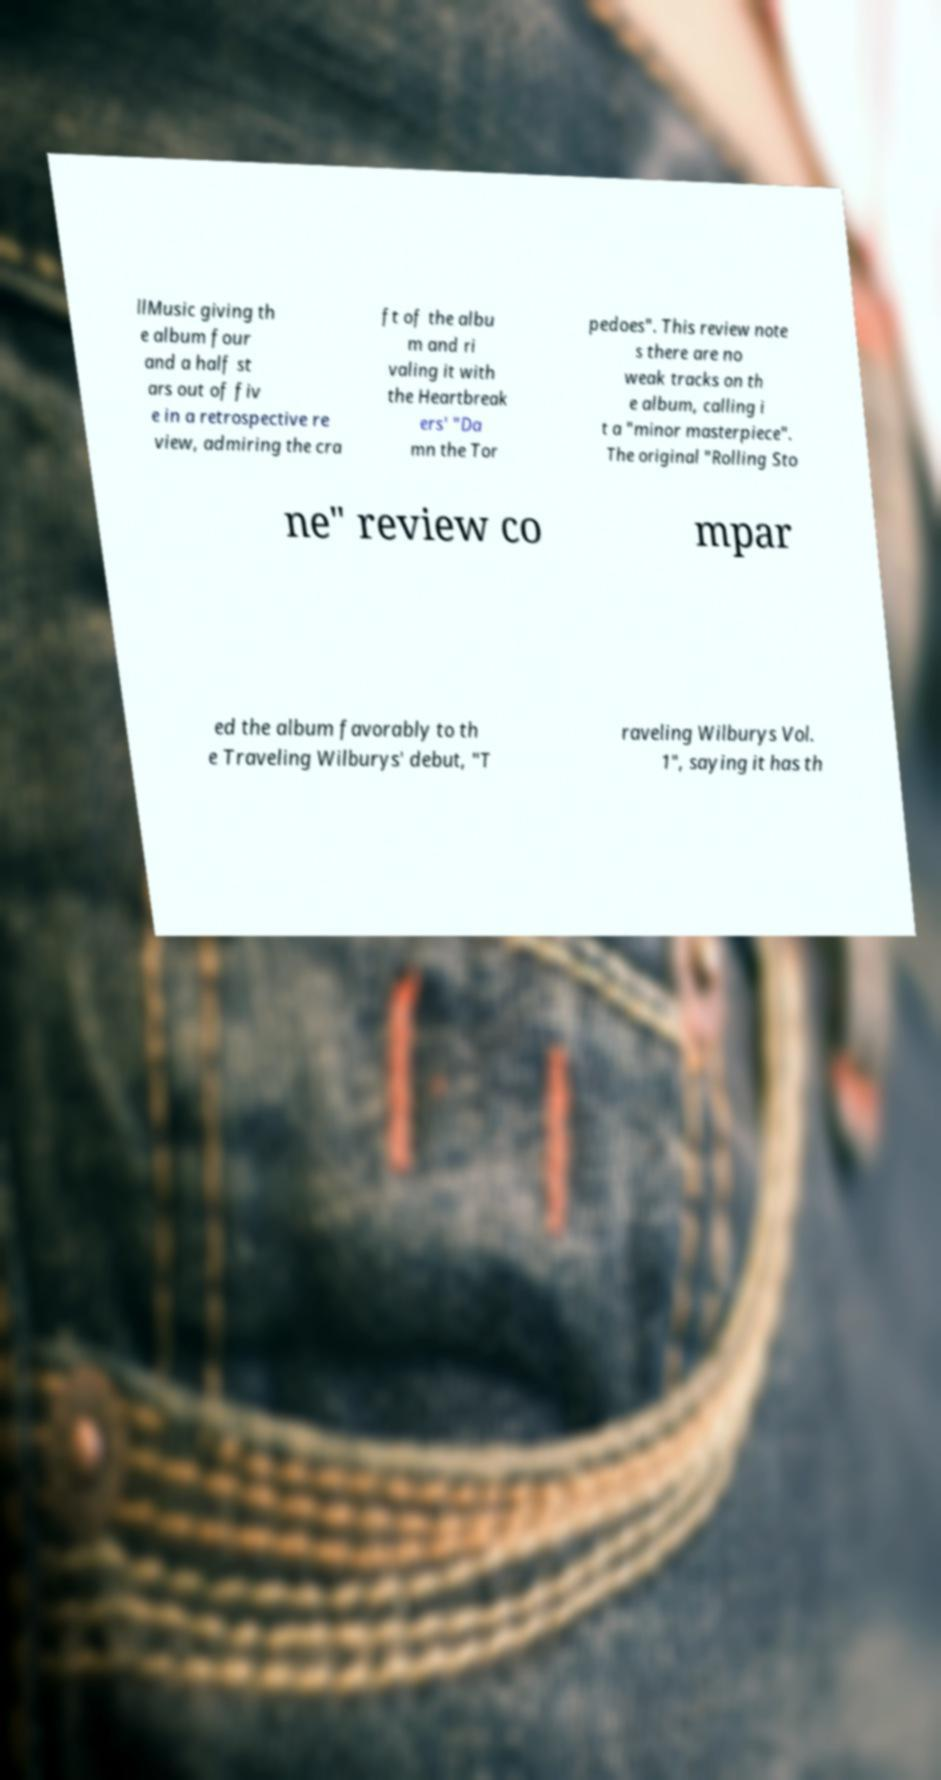What messages or text are displayed in this image? I need them in a readable, typed format. llMusic giving th e album four and a half st ars out of fiv e in a retrospective re view, admiring the cra ft of the albu m and ri valing it with the Heartbreak ers' "Da mn the Tor pedoes". This review note s there are no weak tracks on th e album, calling i t a "minor masterpiece". The original "Rolling Sto ne" review co mpar ed the album favorably to th e Traveling Wilburys' debut, "T raveling Wilburys Vol. 1", saying it has th 